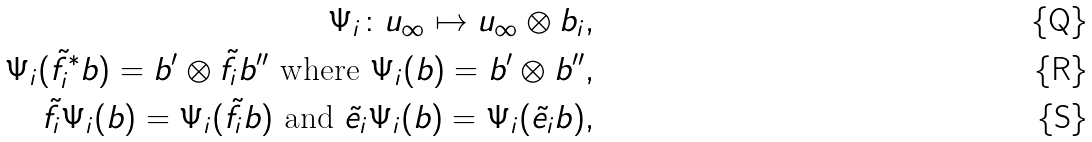Convert formula to latex. <formula><loc_0><loc_0><loc_500><loc_500>\Psi _ { i } \colon u _ { \infty } \mapsto u _ { \infty } \otimes b _ { i } , \\ \Psi _ { i } ( \tilde { f } _ { i } ^ { \ast } b ) = b ^ { \prime } \otimes \tilde { f } _ { i } b ^ { \prime \prime } \text { where } \Psi _ { i } ( b ) = b ^ { \prime } \otimes b ^ { \prime \prime } , \\ \tilde { f } _ { i } \Psi _ { i } ( b ) = \Psi _ { i } ( \tilde { f } _ { i } b ) \text { and } \tilde { e } _ { i } \Psi _ { i } ( b ) = \Psi _ { i } ( \tilde { e } _ { i } b ) ,</formula> 